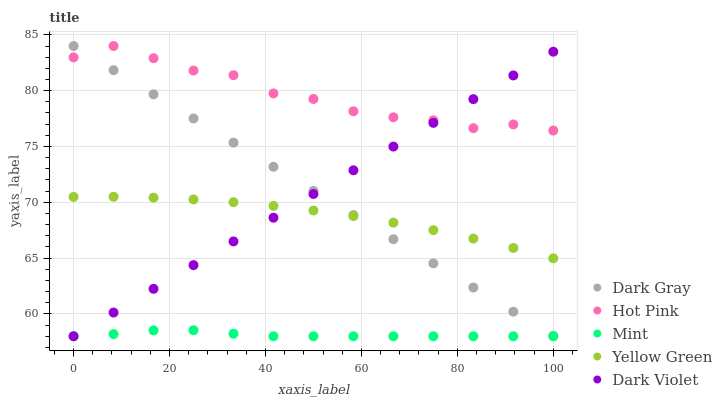Does Mint have the minimum area under the curve?
Answer yes or no. Yes. Does Hot Pink have the maximum area under the curve?
Answer yes or no. Yes. Does Hot Pink have the minimum area under the curve?
Answer yes or no. No. Does Mint have the maximum area under the curve?
Answer yes or no. No. Is Dark Violet the smoothest?
Answer yes or no. Yes. Is Hot Pink the roughest?
Answer yes or no. Yes. Is Mint the smoothest?
Answer yes or no. No. Is Mint the roughest?
Answer yes or no. No. Does Mint have the lowest value?
Answer yes or no. Yes. Does Hot Pink have the lowest value?
Answer yes or no. No. Does Hot Pink have the highest value?
Answer yes or no. Yes. Does Mint have the highest value?
Answer yes or no. No. Is Mint less than Dark Gray?
Answer yes or no. Yes. Is Hot Pink greater than Mint?
Answer yes or no. Yes. Does Yellow Green intersect Dark Violet?
Answer yes or no. Yes. Is Yellow Green less than Dark Violet?
Answer yes or no. No. Is Yellow Green greater than Dark Violet?
Answer yes or no. No. Does Mint intersect Dark Gray?
Answer yes or no. No. 